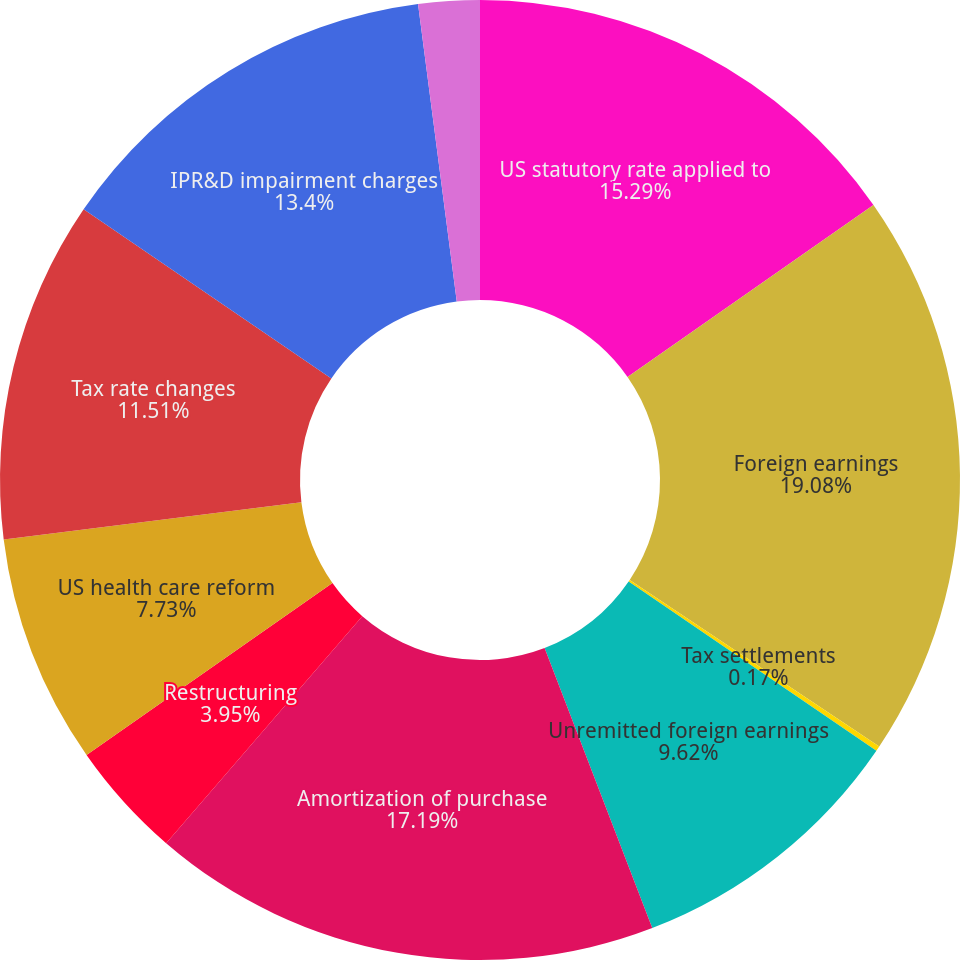<chart> <loc_0><loc_0><loc_500><loc_500><pie_chart><fcel>US statutory rate applied to<fcel>Foreign earnings<fcel>Tax settlements<fcel>Unremitted foreign earnings<fcel>Amortization of purchase<fcel>Restructuring<fcel>US health care reform<fcel>Tax rate changes<fcel>IPR&D impairment charges<fcel>State taxes<nl><fcel>15.29%<fcel>19.07%<fcel>0.17%<fcel>9.62%<fcel>17.18%<fcel>3.95%<fcel>7.73%<fcel>11.51%<fcel>13.4%<fcel>2.06%<nl></chart> 